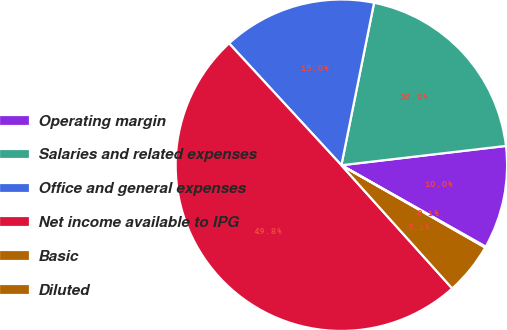Convert chart. <chart><loc_0><loc_0><loc_500><loc_500><pie_chart><fcel>Operating margin<fcel>Salaries and related expenses<fcel>Office and general expenses<fcel>Net income available to IPG<fcel>Basic<fcel>Diluted<nl><fcel>10.04%<fcel>19.98%<fcel>15.01%<fcel>49.81%<fcel>5.07%<fcel>0.09%<nl></chart> 